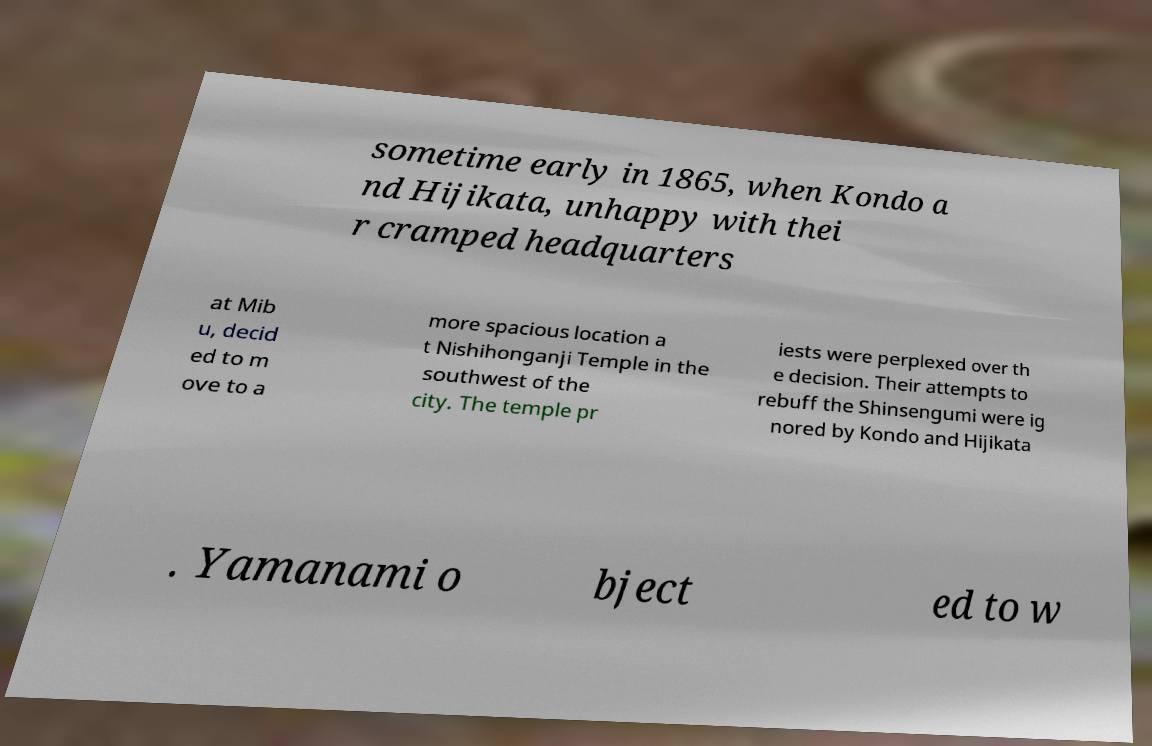There's text embedded in this image that I need extracted. Can you transcribe it verbatim? sometime early in 1865, when Kondo a nd Hijikata, unhappy with thei r cramped headquarters at Mib u, decid ed to m ove to a more spacious location a t Nishihonganji Temple in the southwest of the city. The temple pr iests were perplexed over th e decision. Their attempts to rebuff the Shinsengumi were ig nored by Kondo and Hijikata . Yamanami o bject ed to w 